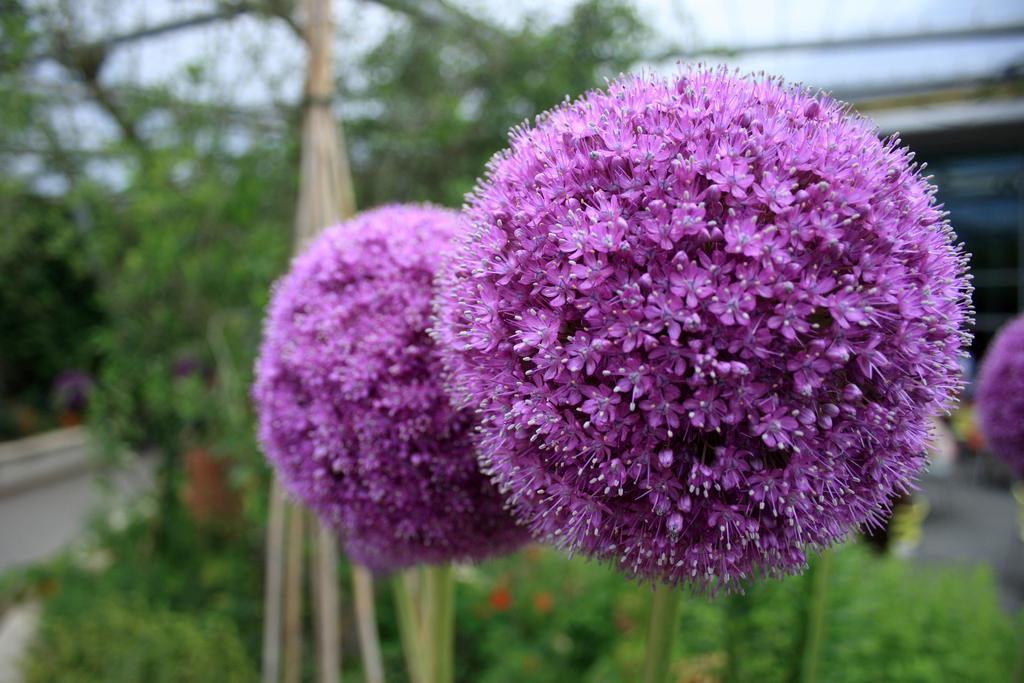In one or two sentences, can you explain what this image depicts? This picture is clicked outside. On the right we can see the two flowers. In the foreground we can see the plants and some objects. In the background there is a sky, trees and some other objects. 